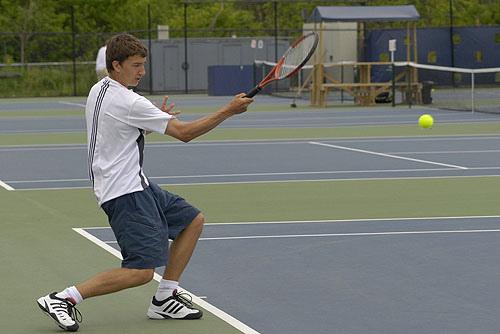Is the tennis ball on the ground?
Concise answer only. No. What color is the ball?
Answer briefly. Yellow. Is the player on a center court?
Write a very short answer. No. Is the man professional?
Quick response, please. No. Is the man focused?
Write a very short answer. Yes. Is the man wearing pants?
Answer briefly. No. 